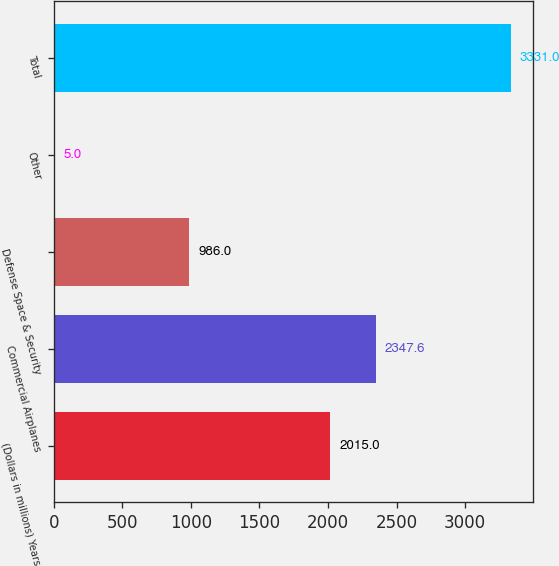Convert chart. <chart><loc_0><loc_0><loc_500><loc_500><bar_chart><fcel>(Dollars in millions) Years<fcel>Commercial Airplanes<fcel>Defense Space & Security<fcel>Other<fcel>Total<nl><fcel>2015<fcel>2347.6<fcel>986<fcel>5<fcel>3331<nl></chart> 